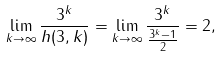<formula> <loc_0><loc_0><loc_500><loc_500>\lim _ { k \to \infty } \frac { 3 ^ { k } } { h ( 3 , k ) } = \lim _ { k \to \infty } \frac { 3 ^ { k } } { \frac { 3 ^ { k } - 1 } { 2 } } = 2 ,</formula> 